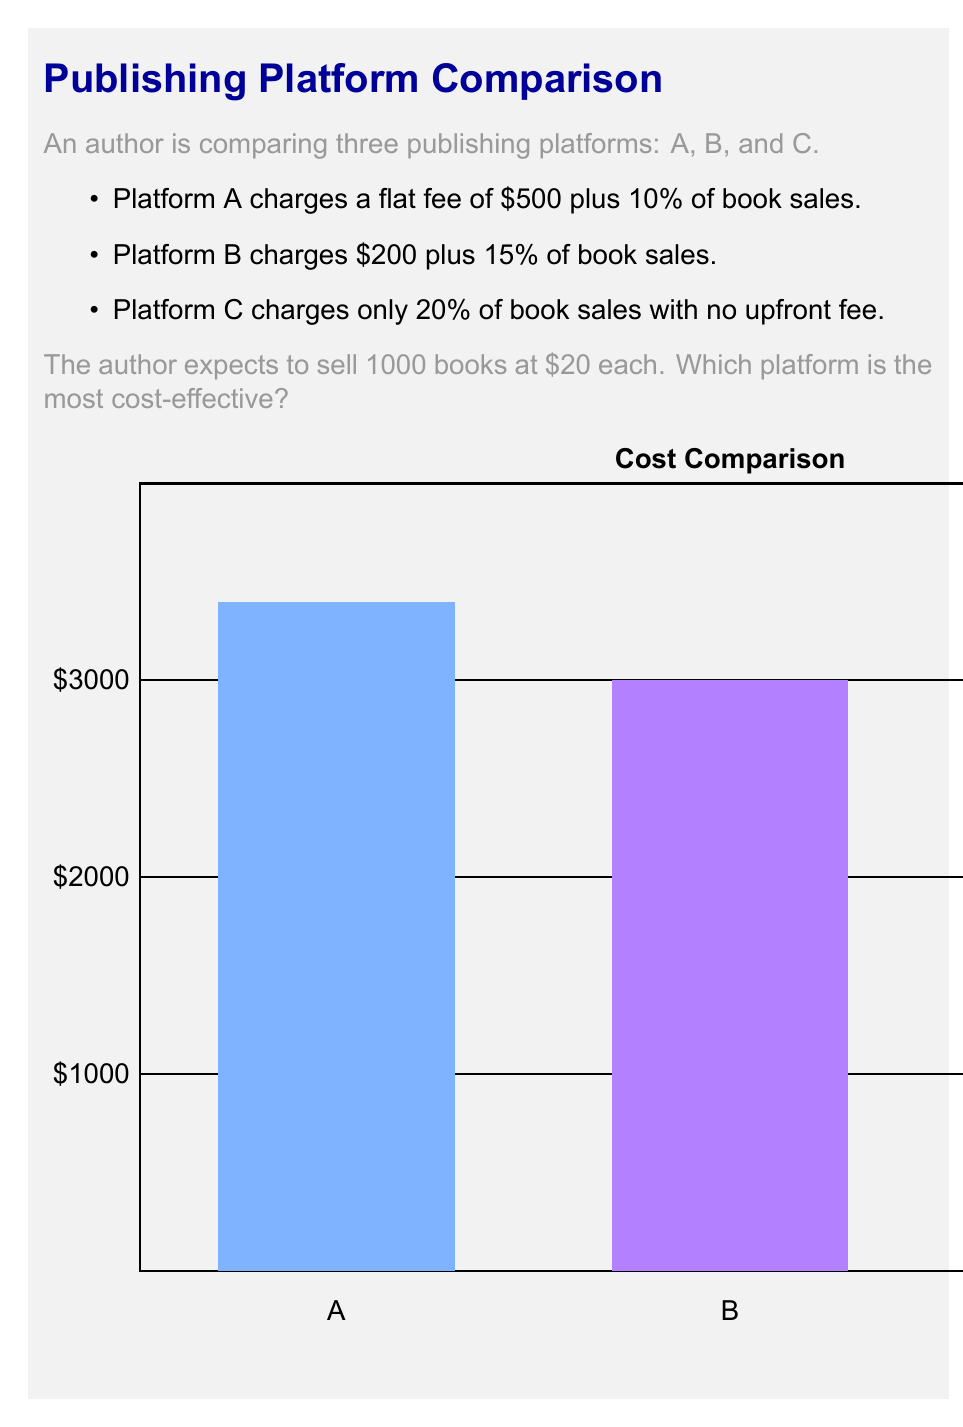Solve this math problem. Let's calculate the total cost for each platform:

1. Platform A:
   - Flat fee: $500
   - Commission: 10% of $20 * 1000 = $2000
   - Total cost: $500 + $2000 = $2500

2. Platform B:
   - Flat fee: $200
   - Commission: 15% of $20 * 1000 = $3000
   - Total cost: $200 + $3000 = $3200

3. Platform C:
   - No flat fee
   - Commission: 20% of $20 * 1000 = $4000
   - Total cost: $4000

To find the most cost-effective platform, we compare the total costs:

$$\begin{align*}
\text{Platform A}: &\$2500 \\
\text{Platform B}: &\$3200 \\
\text{Platform C}: &\$4000
\end{align*}$$

Platform A has the lowest total cost, making it the most cost-effective option for the author.
Answer: Platform A 